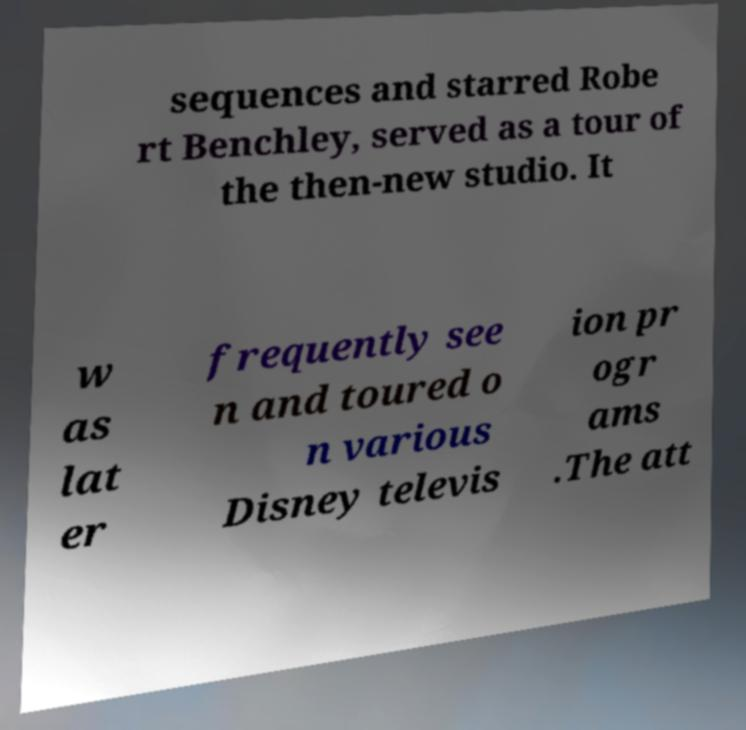Can you read and provide the text displayed in the image?This photo seems to have some interesting text. Can you extract and type it out for me? sequences and starred Robe rt Benchley, served as a tour of the then-new studio. It w as lat er frequently see n and toured o n various Disney televis ion pr ogr ams .The att 